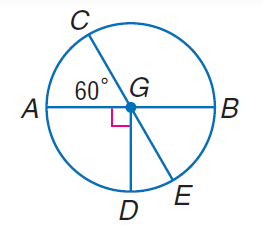What relationship can we observe between the angle measures in the diagram? In the diagram, you can see that angle CGE is a central angle of the circle, which means its measure is equal to the measure of the arc it intercepts - arc CE. Since arc CE is part of the entire circumference of the circle and no other arc measures are given, we cannot determine its length or the measure of angle CGE without additional information. Another observable relationship is that all the radii of the circle, such as DG, CG, and EG, are equal in length. The line segments divide the circle into equal parts, indicating that angles CGD, DGE, and EGC are all central angles and would be equal if the arcs they intercept are equal. 